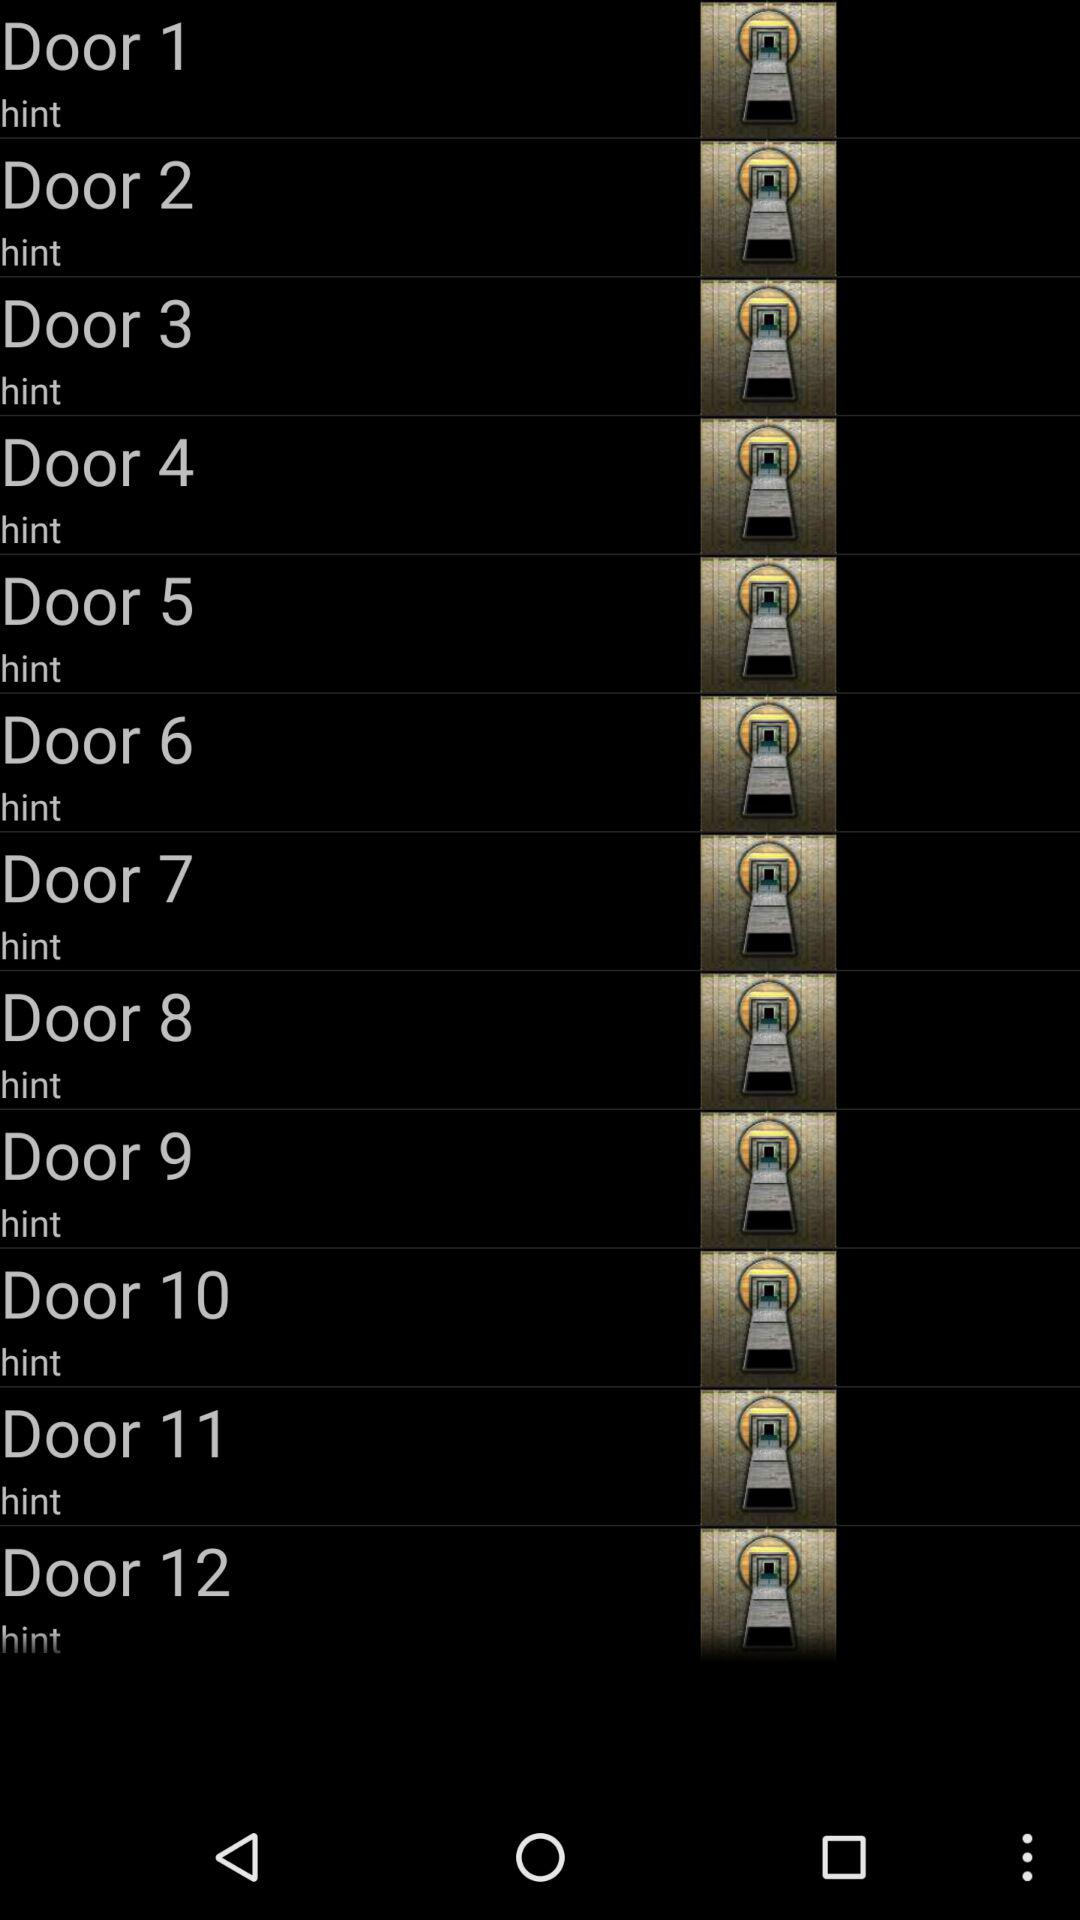How many doors are there in total?
Answer the question using a single word or phrase. 12 